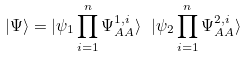<formula> <loc_0><loc_0><loc_500><loc_500>| \Psi \rangle = | \psi _ { 1 } \prod _ { i = 1 } ^ { n } \Psi _ { A A } ^ { 1 , i } \rangle \ | \psi _ { 2 } \prod _ { i = 1 } ^ { n } \Psi _ { A A } ^ { 2 , i } \rangle</formula> 